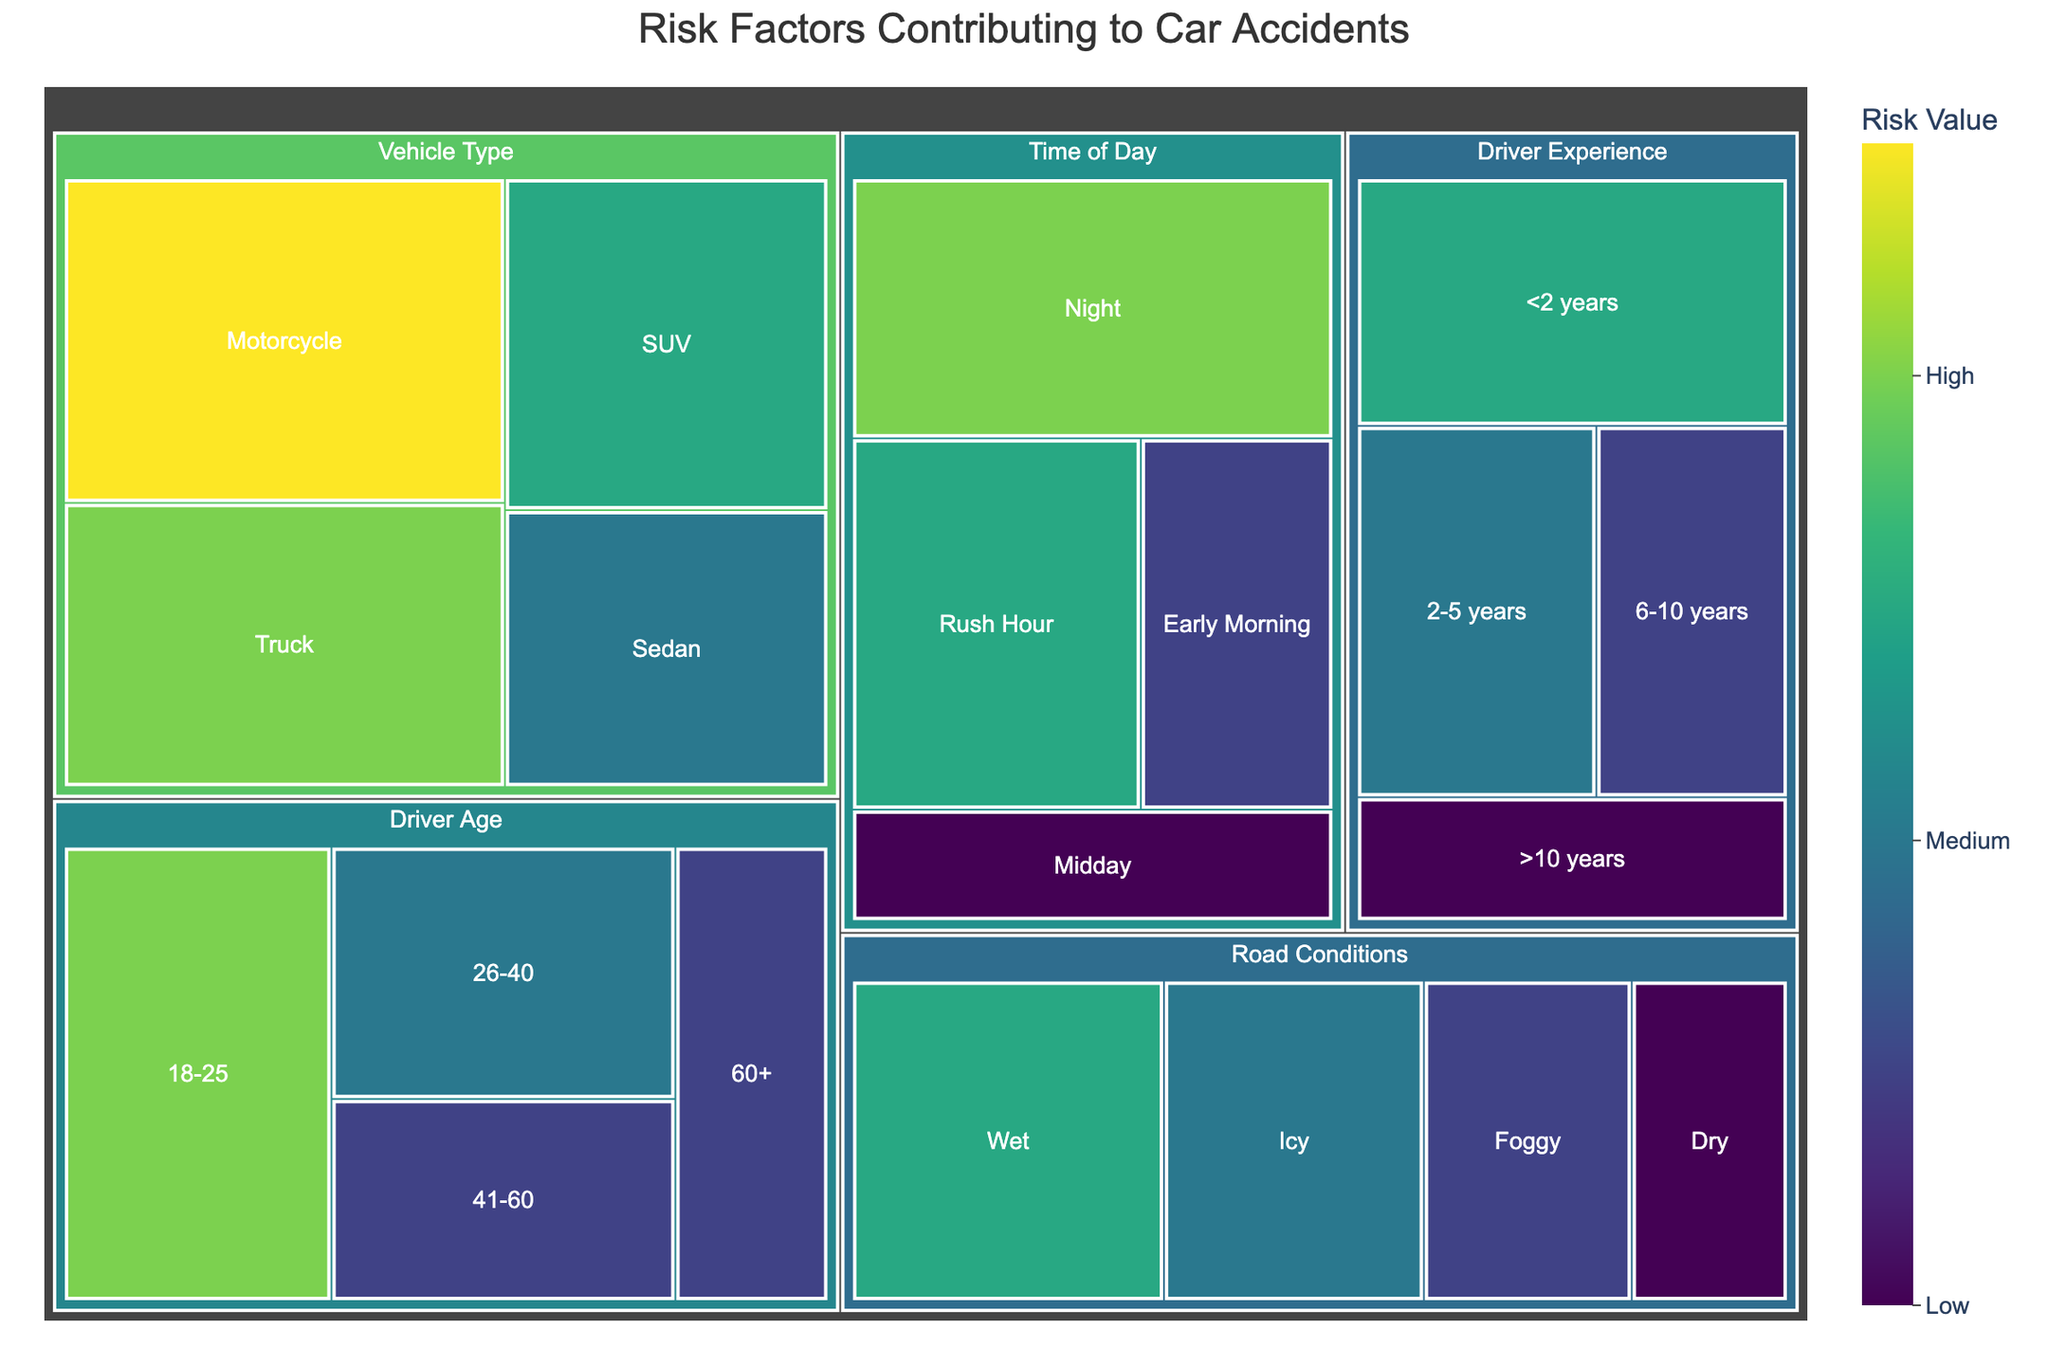What is the main title of the figure? The main title of the figure is usually placed at the top center of the plot. From the visualization, you can read the title as "Risk Factors Contributing to Car Accidents".
Answer: Risk Factors Contributing to Car Accidents How many categories are there in the figure? The figure depicts different categories which are denoted by the largest rectangular sections in the Treemap. The labels on these large sections indicate the categories. By counting these labels, we can determine there are five categories: Driver Age, Road Conditions, Driver Experience, Time of Day, and Vehicle Type.
Answer: Five Which subcategory in the "Driver Age" category has the highest risk value? In the "Driver Age" category, the subcategories show different age ranges. By observing the sizes and the numerical risk values displayed, the subcategory "18-25" has the highest risk value.
Answer: 18-25 What is the combined risk value for "Wet" and "Icy" within the Road Conditions category? Add the risk values for "Wet" and "Icy" subcategories. "Wet" has a risk value of 30, and "Icy" has a risk value of 25. Summing these two values, 30 + 25 = 55.
Answer: 55 Which subcategory shows the highest risk value in the Time of Day category, and what is its value? By examining the subcategories under the Time of Day category, observe the risk values. The "Night" subcategory has the highest risk value at 35.
Answer: Night, 35 Compare the risk values for the subcategories under the "Driver Experience" category. Which subcategory has the lowest risk value? Refer to the subcategories under the "Driver Experience" category and compare their risk values. The subcategory ">10 years" has the lowest risk value at 15.
Answer: >10 years Which vehicle type poses the highest risk value according to the Treemap? Look at the subcategories under the Vehicle Type category and identify the one with the highest displayed risk value. The subcategory "Motorcycle" has the highest risk value at 40.
Answer: Motorcycle What is the total risk value for all Vehicle Types? Sum up the risk values for all subcategories under the Vehicle Type category: Sedan (25), SUV (30), Truck (35), and Motorcycle (40). Therefore, the total risk value is 25 + 30 + 35 + 40 = 130.
Answer: 130 How does the risk value for "Night" in Time of Day compare to the risk value for "18-25" in Driver Age? Compare the numerical values for "Night" subcategory in Time of Day and "18-25" in Driver Age. Both values are 35, so they have the same risk value.
Answer: Equal 